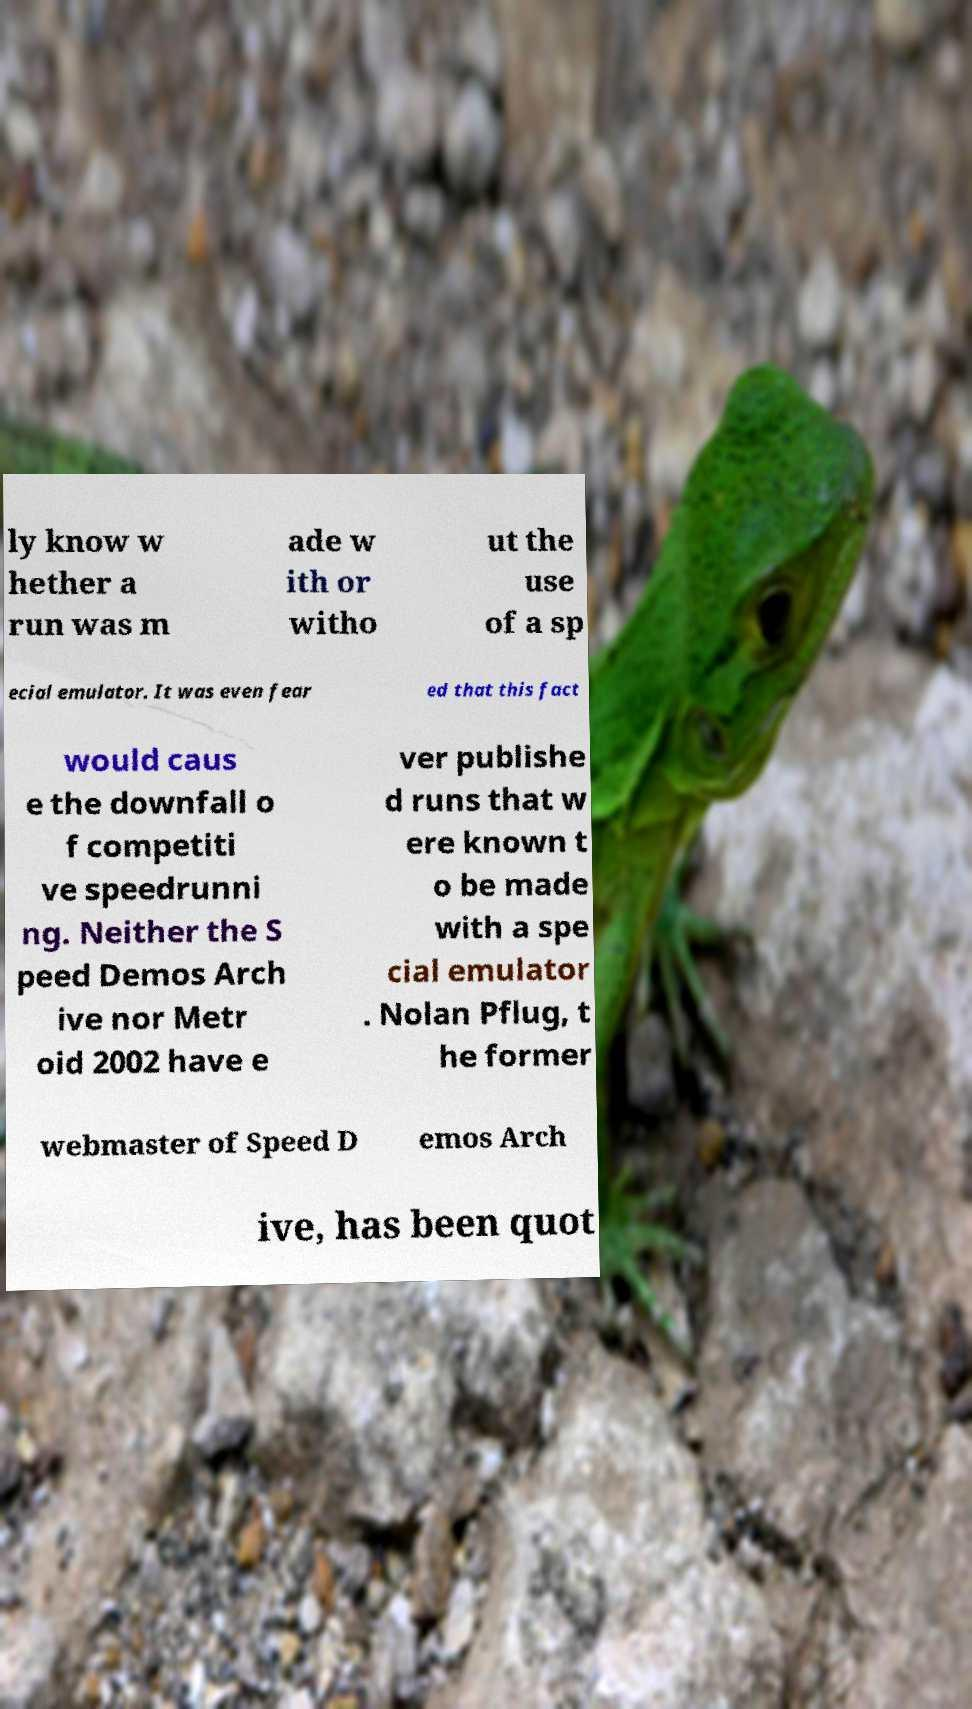Please read and relay the text visible in this image. What does it say? ly know w hether a run was m ade w ith or witho ut the use of a sp ecial emulator. It was even fear ed that this fact would caus e the downfall o f competiti ve speedrunni ng. Neither the S peed Demos Arch ive nor Metr oid 2002 have e ver publishe d runs that w ere known t o be made with a spe cial emulator . Nolan Pflug, t he former webmaster of Speed D emos Arch ive, has been quot 